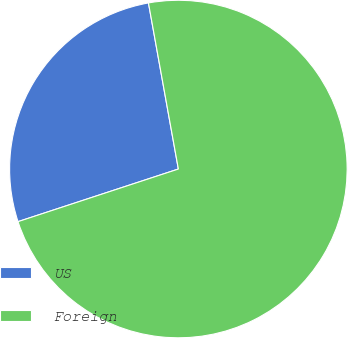Convert chart to OTSL. <chart><loc_0><loc_0><loc_500><loc_500><pie_chart><fcel>US<fcel>Foreign<nl><fcel>27.21%<fcel>72.79%<nl></chart> 